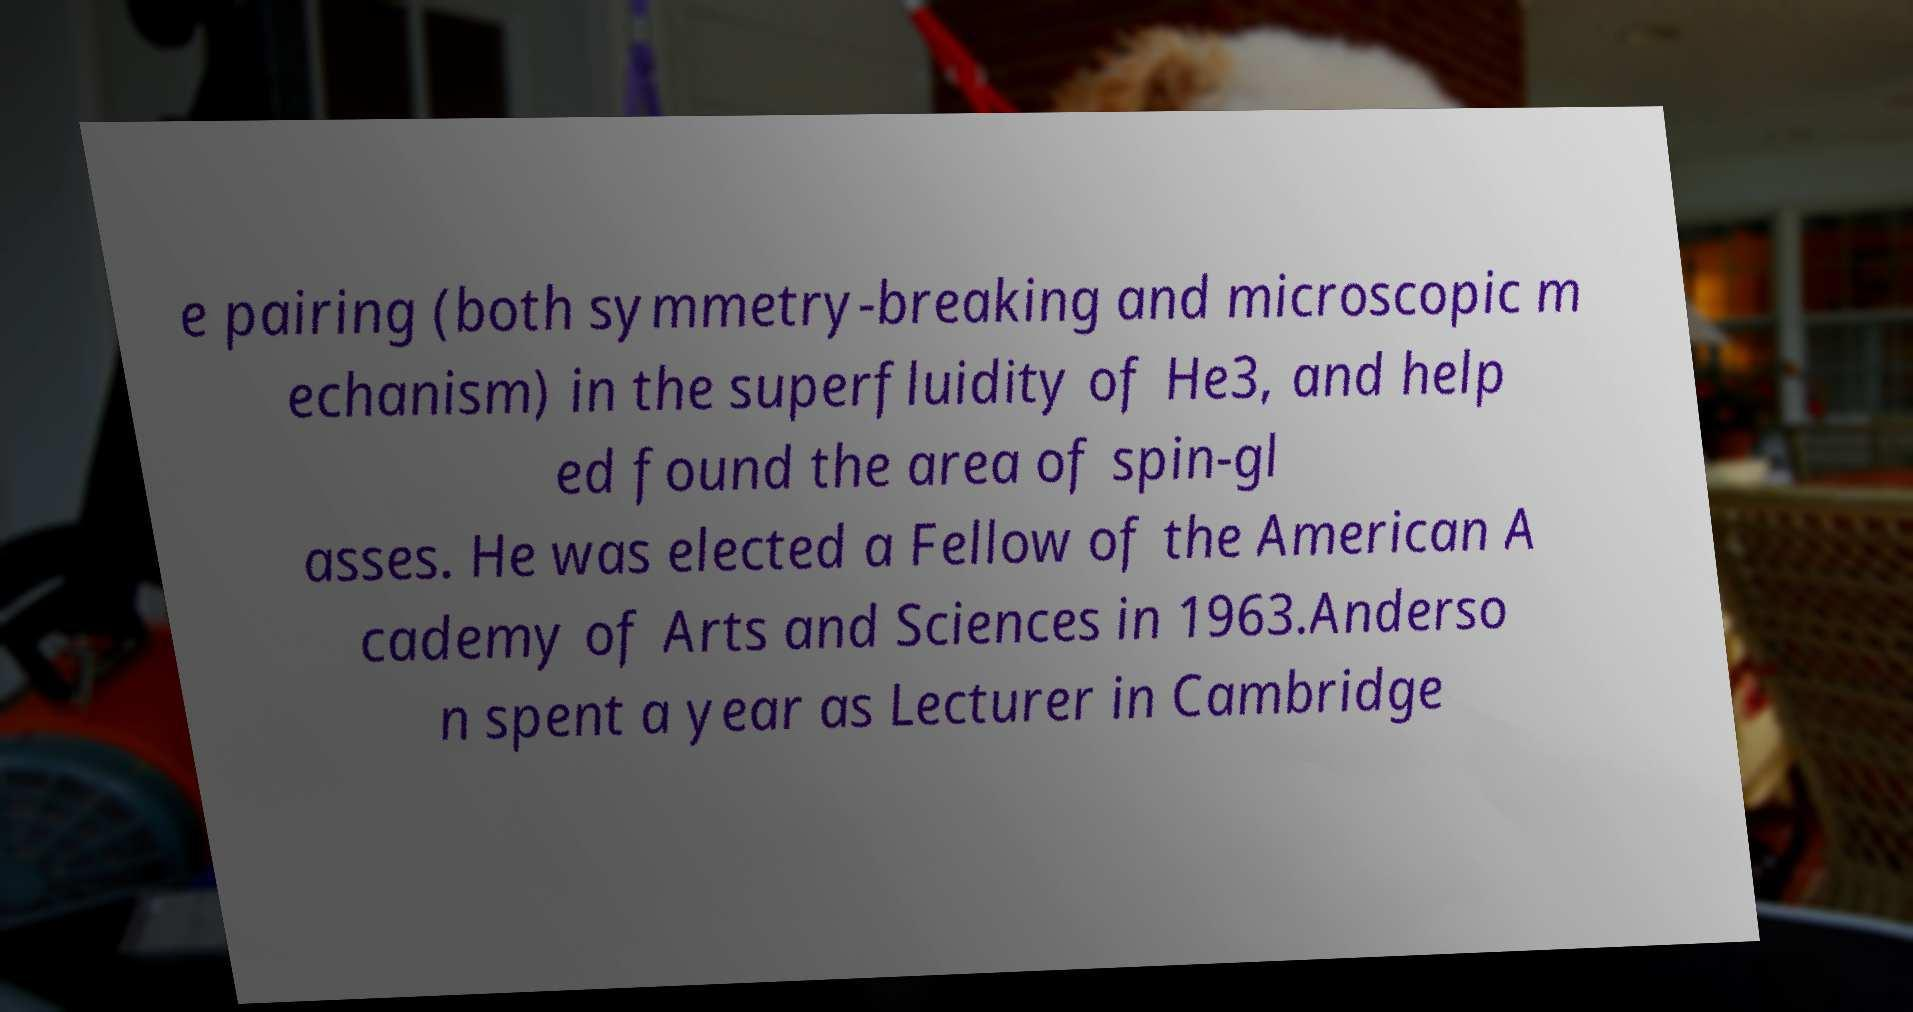For documentation purposes, I need the text within this image transcribed. Could you provide that? e pairing (both symmetry-breaking and microscopic m echanism) in the superfluidity of He3, and help ed found the area of spin-gl asses. He was elected a Fellow of the American A cademy of Arts and Sciences in 1963.Anderso n spent a year as Lecturer in Cambridge 